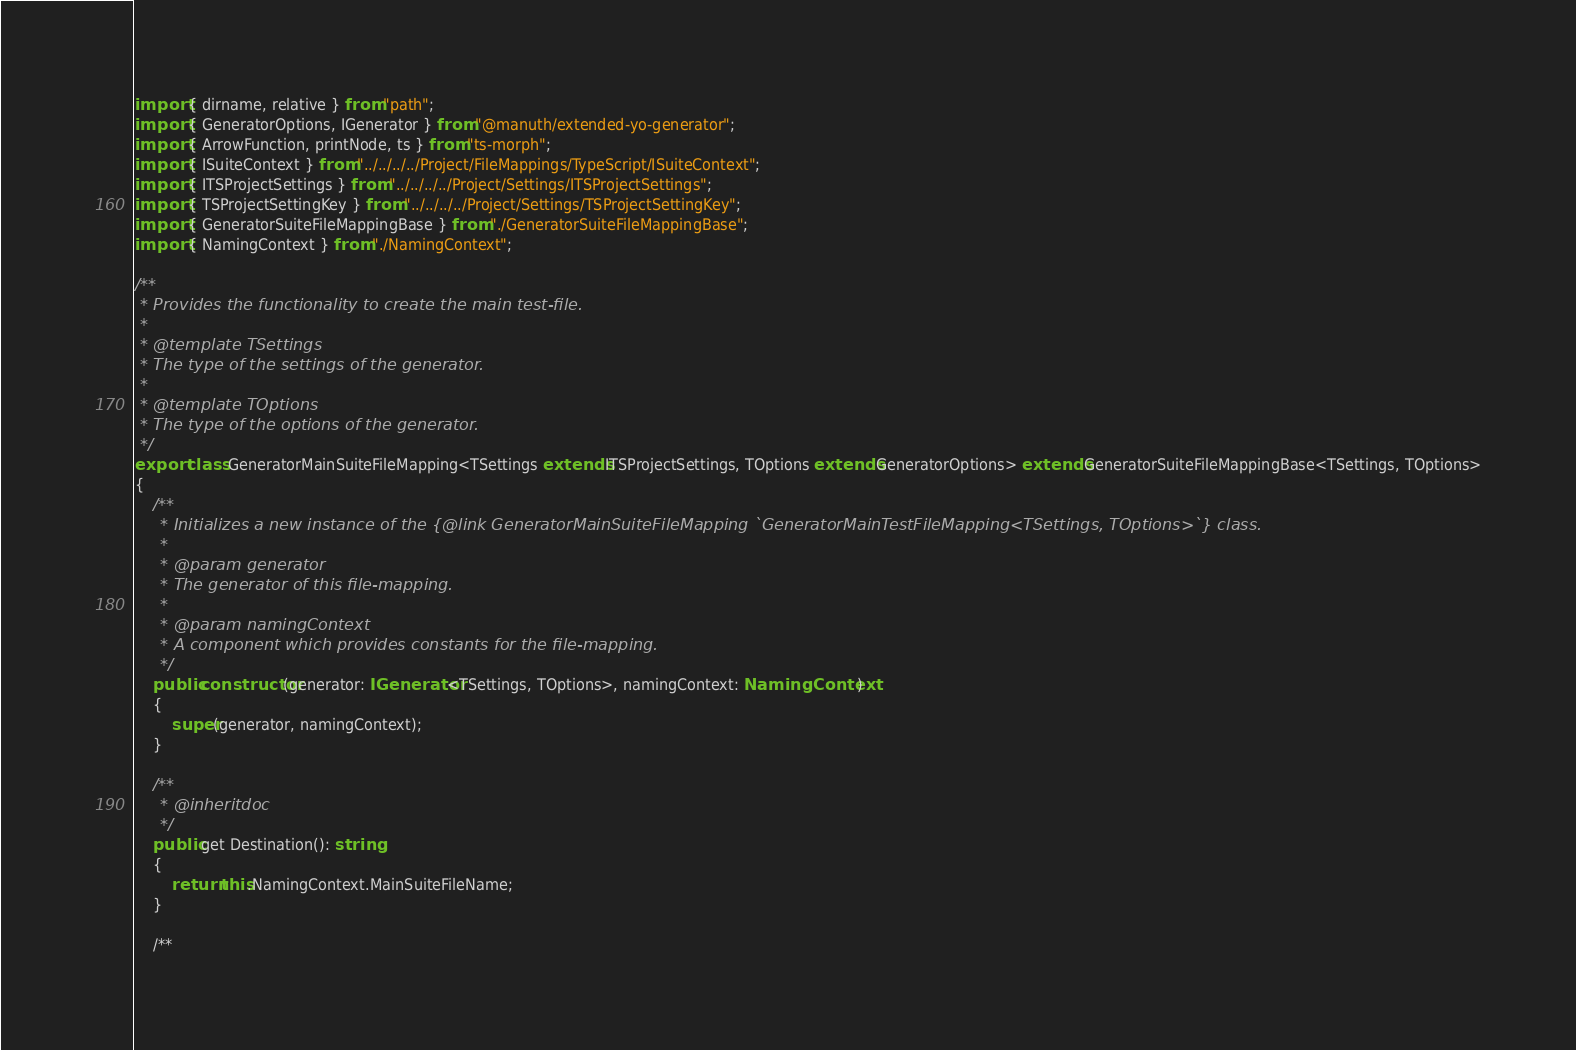<code> <loc_0><loc_0><loc_500><loc_500><_TypeScript_>import { dirname, relative } from "path";
import { GeneratorOptions, IGenerator } from "@manuth/extended-yo-generator";
import { ArrowFunction, printNode, ts } from "ts-morph";
import { ISuiteContext } from "../../../../Project/FileMappings/TypeScript/ISuiteContext";
import { ITSProjectSettings } from "../../../../Project/Settings/ITSProjectSettings";
import { TSProjectSettingKey } from "../../../../Project/Settings/TSProjectSettingKey";
import { GeneratorSuiteFileMappingBase } from "./GeneratorSuiteFileMappingBase";
import { NamingContext } from "./NamingContext";

/**
 * Provides the functionality to create the main test-file.
 *
 * @template TSettings
 * The type of the settings of the generator.
 *
 * @template TOptions
 * The type of the options of the generator.
 */
export class GeneratorMainSuiteFileMapping<TSettings extends ITSProjectSettings, TOptions extends GeneratorOptions> extends GeneratorSuiteFileMappingBase<TSettings, TOptions>
{
    /**
     * Initializes a new instance of the {@link GeneratorMainSuiteFileMapping `GeneratorMainTestFileMapping<TSettings, TOptions>`} class.
     *
     * @param generator
     * The generator of this file-mapping.
     *
     * @param namingContext
     * A component which provides constants for the file-mapping.
     */
    public constructor(generator: IGenerator<TSettings, TOptions>, namingContext: NamingContext)
    {
        super(generator, namingContext);
    }

    /**
     * @inheritdoc
     */
    public get Destination(): string
    {
        return this.NamingContext.MainSuiteFileName;
    }

    /**</code> 